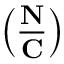Convert formula to latex. <formula><loc_0><loc_0><loc_500><loc_500>\left ( { \frac { N } { C } } \right )</formula> 